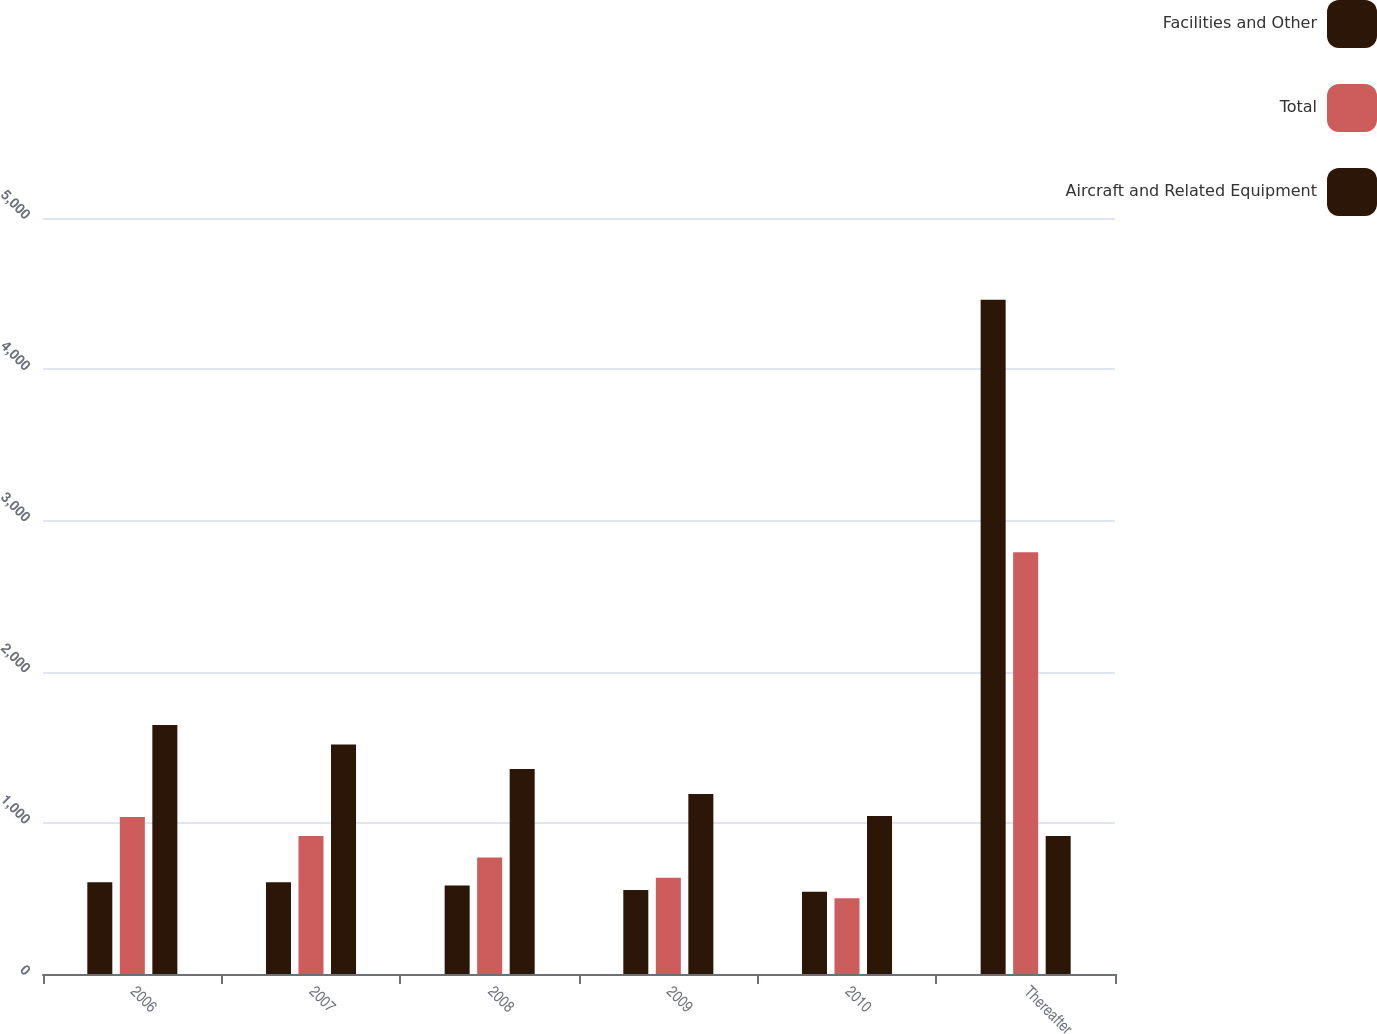<chart> <loc_0><loc_0><loc_500><loc_500><stacked_bar_chart><ecel><fcel>2006<fcel>2007<fcel>2008<fcel>2009<fcel>2010<fcel>Thereafter<nl><fcel>Facilities and Other<fcel>607<fcel>606<fcel>585<fcel>555<fcel>544<fcel>4460<nl><fcel>Total<fcel>1039<fcel>912<fcel>771<fcel>636<fcel>501<fcel>2789<nl><fcel>Aircraft and Related Equipment<fcel>1646<fcel>1518<fcel>1356<fcel>1191<fcel>1045<fcel>912<nl></chart> 